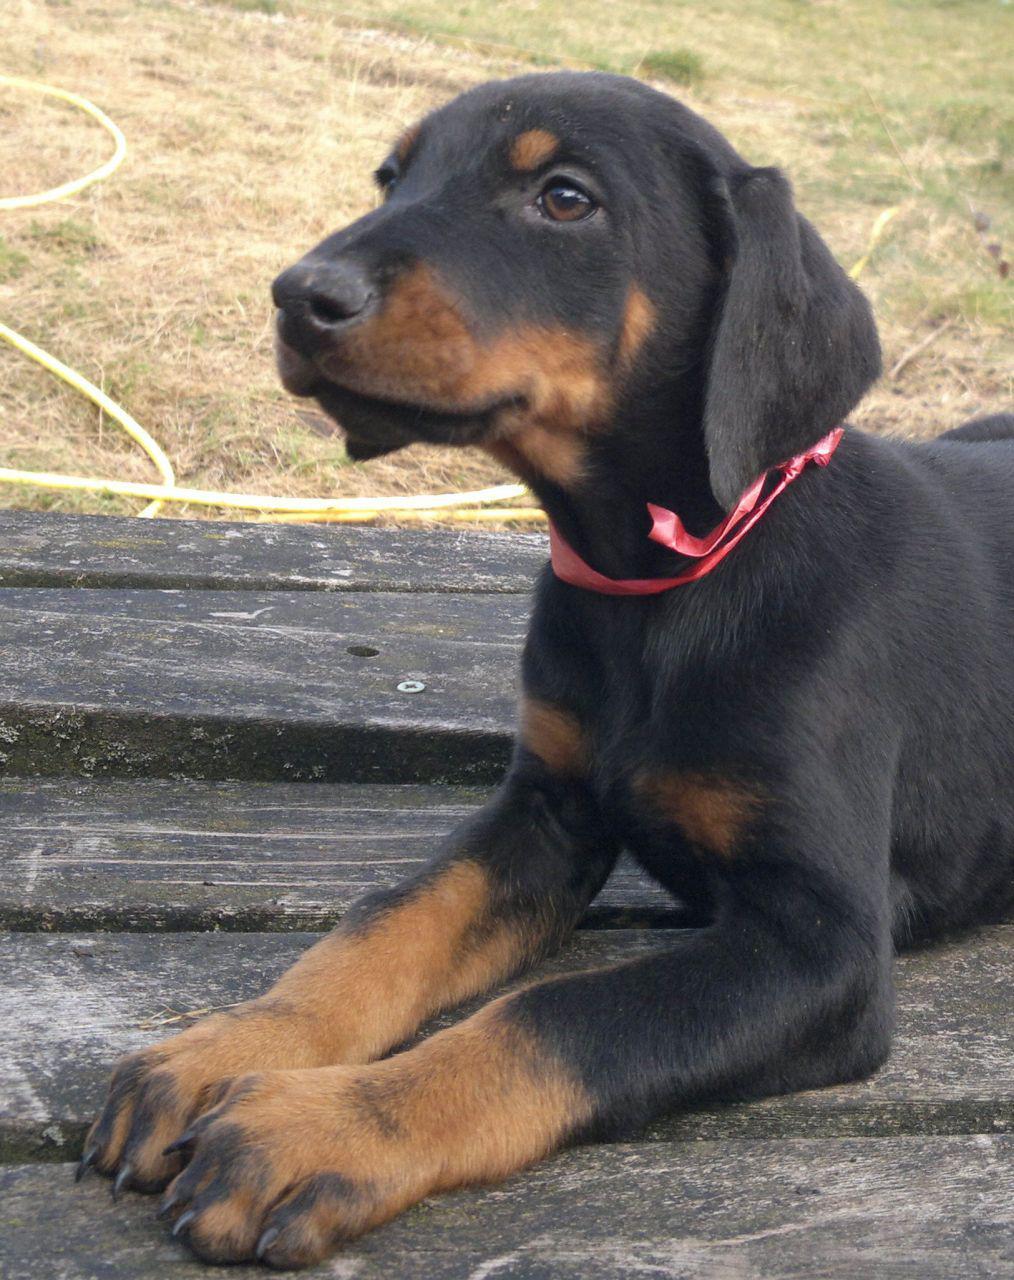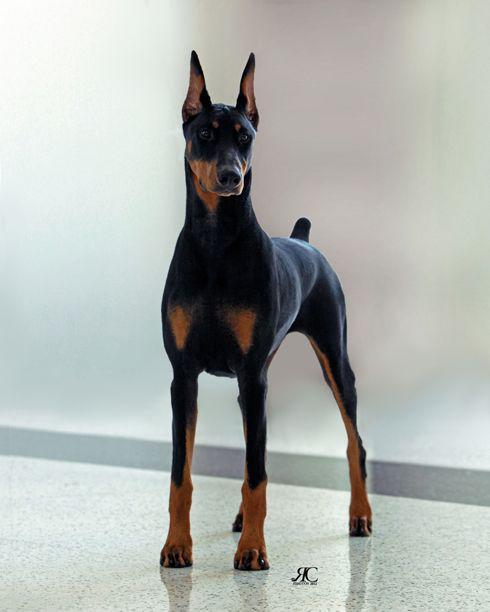The first image is the image on the left, the second image is the image on the right. Evaluate the accuracy of this statement regarding the images: "There is a young puppy in one image.". Is it true? Answer yes or no. Yes. The first image is the image on the left, the second image is the image on the right. For the images displayed, is the sentence "One of the dogs has floppy ears." factually correct? Answer yes or no. Yes. 